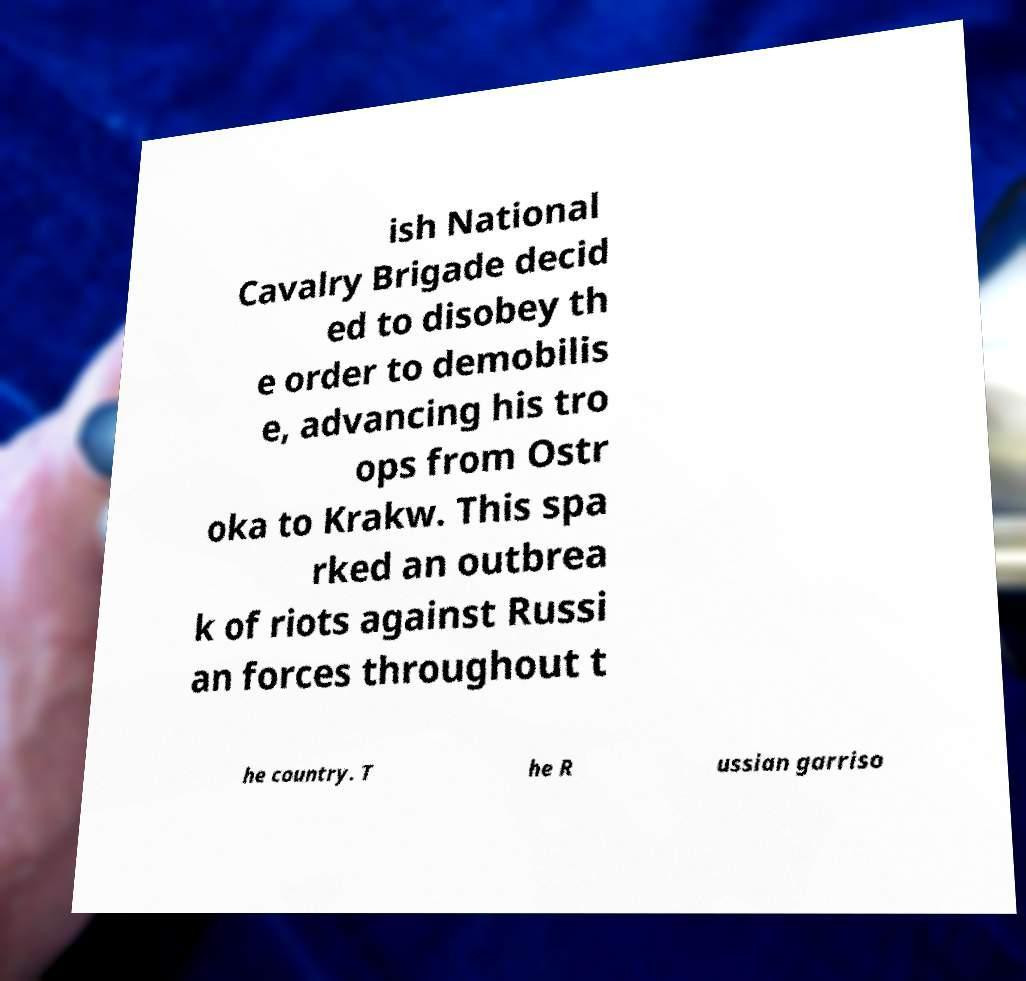Could you assist in decoding the text presented in this image and type it out clearly? ish National Cavalry Brigade decid ed to disobey th e order to demobilis e, advancing his tro ops from Ostr oka to Krakw. This spa rked an outbrea k of riots against Russi an forces throughout t he country. T he R ussian garriso 